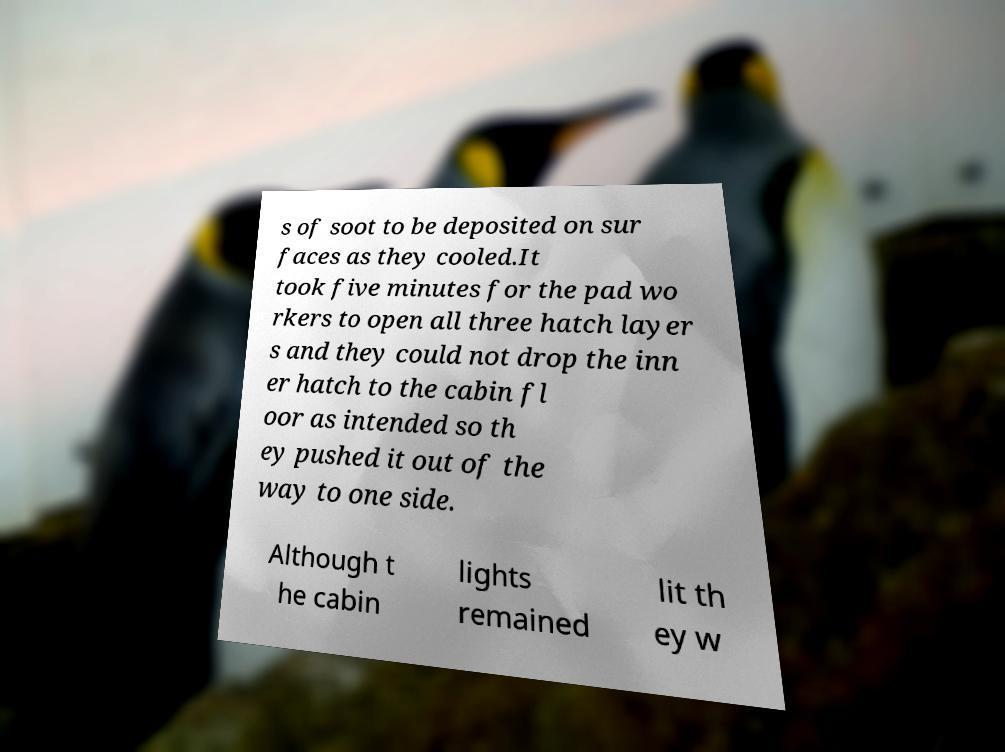Could you extract and type out the text from this image? s of soot to be deposited on sur faces as they cooled.It took five minutes for the pad wo rkers to open all three hatch layer s and they could not drop the inn er hatch to the cabin fl oor as intended so th ey pushed it out of the way to one side. Although t he cabin lights remained lit th ey w 